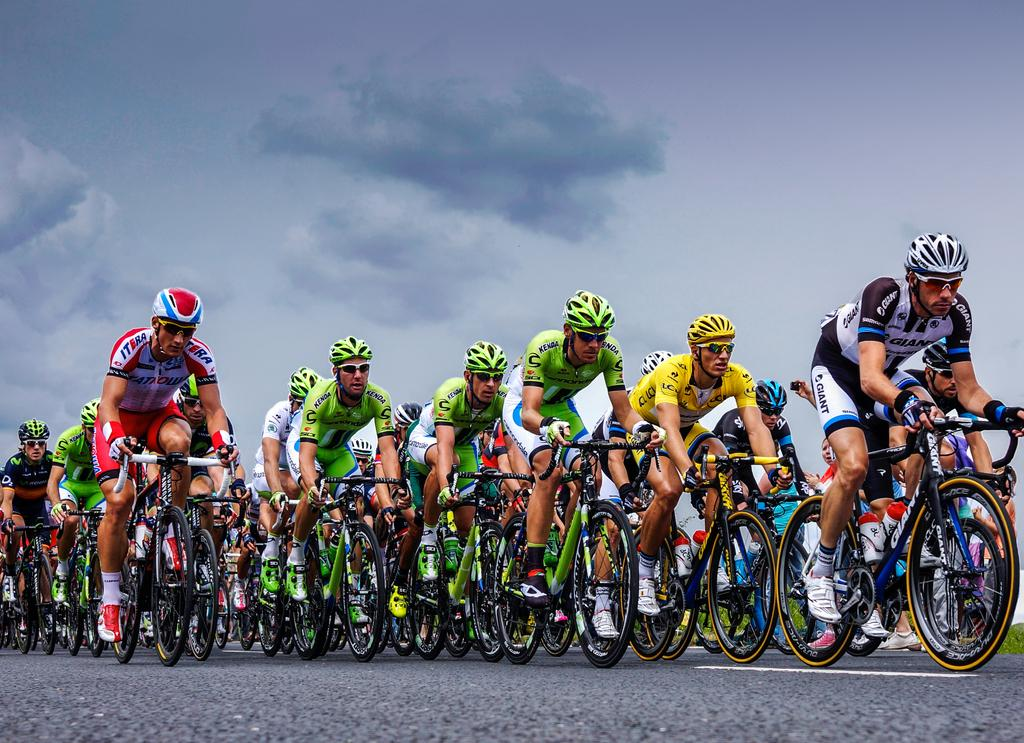How many people are in the image? There are people in the image, but the exact number is not specified. What type of clothing are the people wearing? The people are wearing dresses, helmets, glasses, socks, and shoes. What activity are the people engaged in? The people are riding bicycles. Where are the bicycles located? The bicycles are on the road. What is the weather like in the image? The sky in the background is cloudy, suggesting a potentially overcast or rainy day. What type of noise can be heard coming from the flock of birds in the image? There are no birds or noise present in the image; it features people riding bicycles on the road with a cloudy sky in the background. 